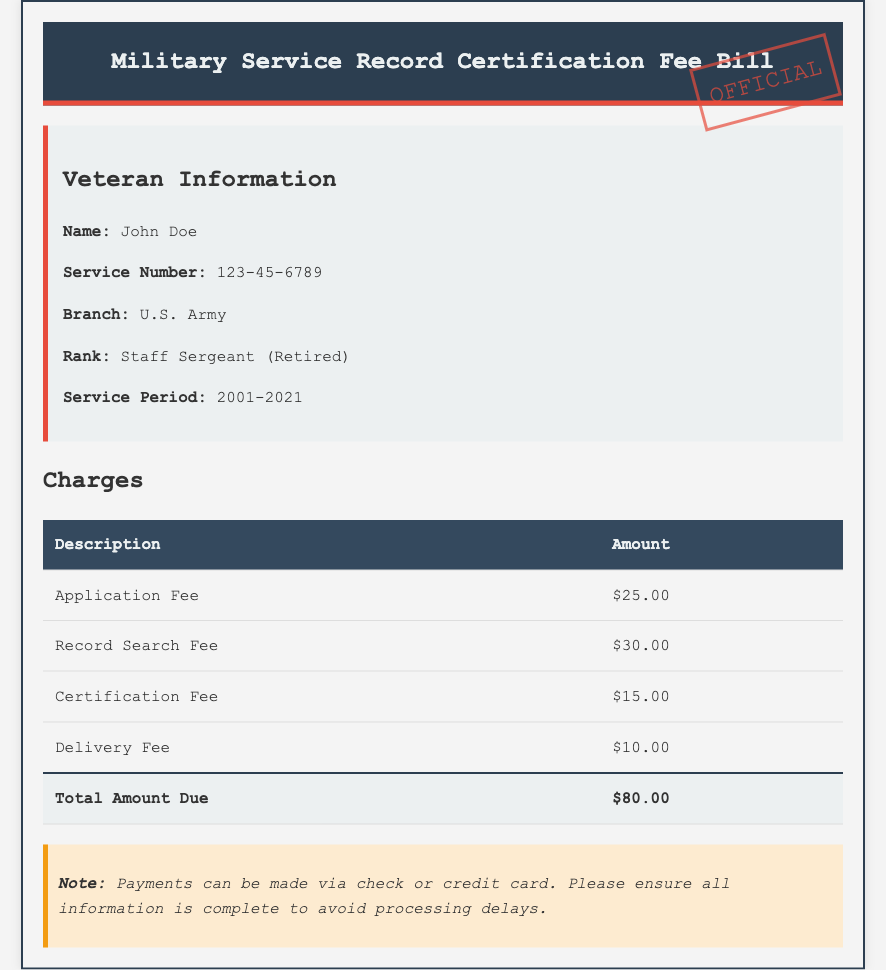What is the veteran's name? The veteran's name is listed in the document under the Veteran Information section.
Answer: John Doe What is the total amount due? The total amount due is highlighted at the bottom of the Charges table in the document.
Answer: $80.00 What is the application fee? The application fee is specified in the Charges table within the document.
Answer: $25.00 What is the service period of the veteran? The service period is provided in the Veteran Information section of the document.
Answer: 2001-2021 What is the delivery fee? The delivery fee can be found in the Charges table in the document.
Answer: $10.00 What branch did the veteran serve in? The veteran's branch of service is mentioned under the Veteran Information section.
Answer: U.S. Army How many fees are listed in the document? The number of fees can be counted from the Charges table in the document.
Answer: 4 What payment methods are accepted? Payment methods are noted at the bottom of the document.
Answer: Check or credit card What rank did the veteran achieve? The rank attained by the veteran is specified in the Veteran Information section of the document.
Answer: Staff Sergeant (Retired) 